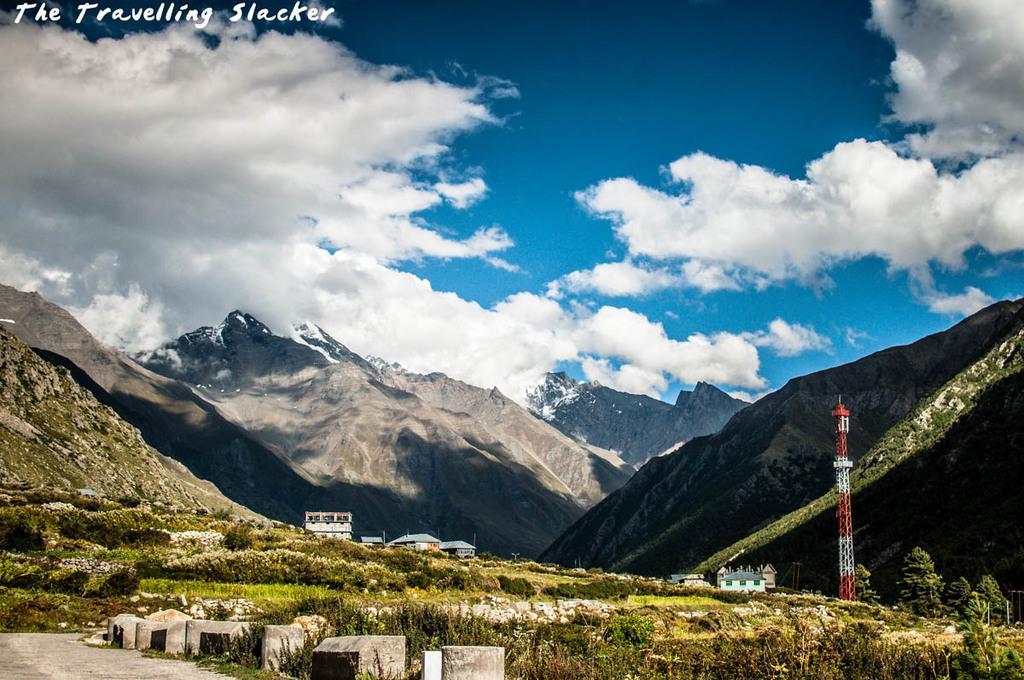Can you describe this image briefly? In this image there is sky, there are clouds, there is the text written on the image, there are buildingś, there are houseś, there are plantś, there are treeś, there are towerś, there is grass. 